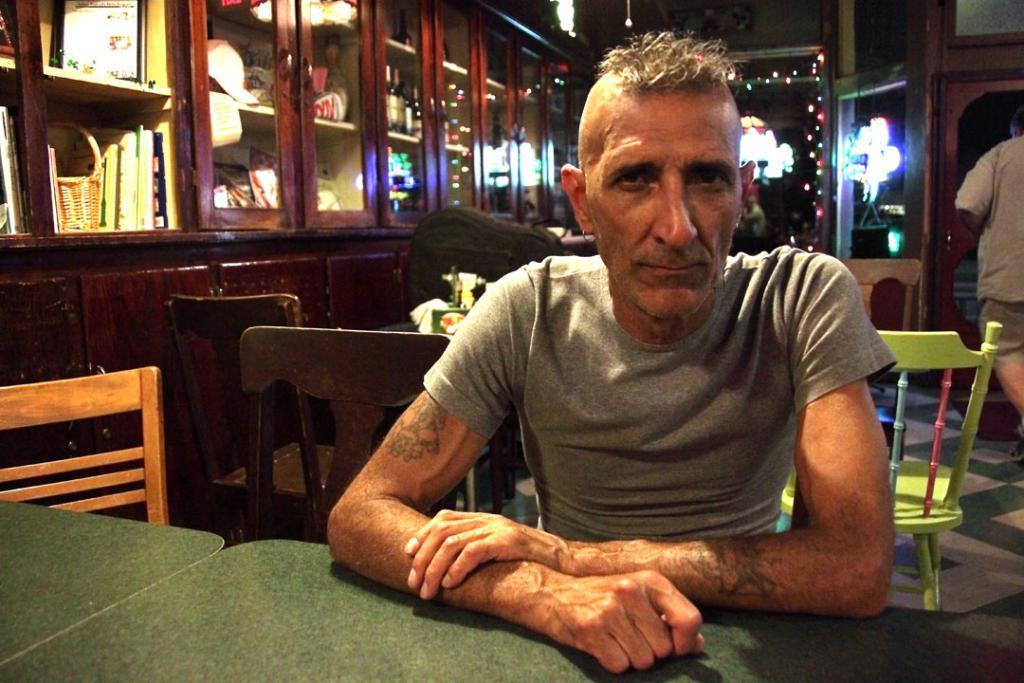Please provide a concise description of this image. This person sitting on the chair and this person walking. We can see objects on the table and chairs. On the background we can see cupboards and wall. This is floor. 